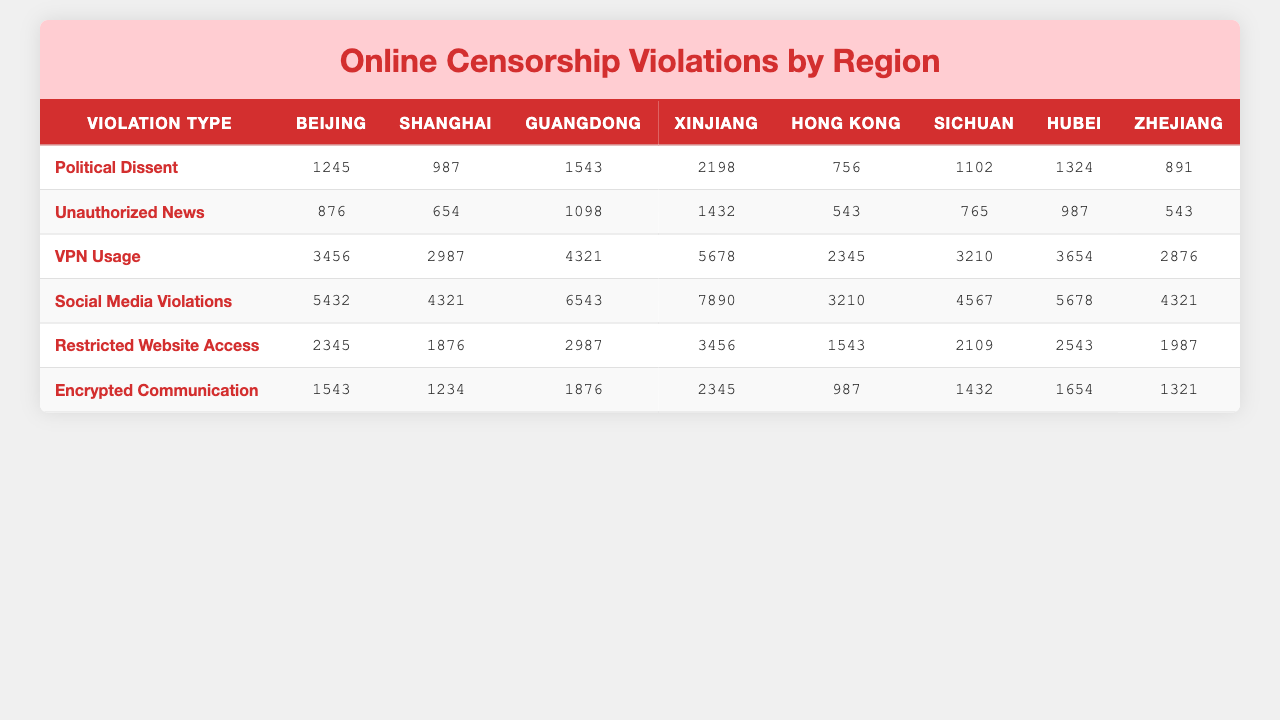What's the total frequency of Political Dissent violations in Beijing? The frequency of Political Dissent violations in Beijing is 1245. Since this is a direct retrieval question, we can simply refer to the number in the table.
Answer: 1245 Which region has the highest frequency of VPN Usage violations? The highest frequency of VPN Usage violations can be found by comparing the numbers across all regions. In this case, Xinjiang has the highest frequency at 5678.
Answer: Xinjiang What is the average frequency of Restricted Website Access violations across all regions? To calculate the average for Restricted Website Access violations, we sum the frequencies (2345 + 1876 + 2987 + 3456 + 1543 + 2109 + 2543 + 1987 = 18656) and divide by the number of regions (8). Thus, the average frequency is 18656 / 8 = 2332.
Answer: 2332 In which region is the frequency of Unauthorized News violations lower than 800? The frequency of Unauthorized News violations is lower than 800 only in Hong Kong (543). Since there is only one instance, we can confirm this directly from the table.
Answer: Hong Kong What is the total frequency of Social Media Violations across all regions combined? To find the total frequency, we sum all the values for Social Media Violations (5432 + 4321 + 6543 + 7890 + 3210 + 4567 + 5678 + 4321 = 40062).
Answer: 40062 Which violation type has the second highest frequency of violations in Shanghai? In Shanghai, looking at the frequencies: the highest violation is VPN Usage (2987), followed by Social Media Violations (4321). Thus, the second highest is Unauthorized News (654).
Answer: Unauthorized News Is the frequency of Encrypted Communication violations higher in Hubei than in Sichuan? The frequency of Encrypted Communication is 1654 in Hubei and 1432 in Sichuan. Since 1654 is greater than 1432, the answer is yes.
Answer: Yes What is the difference in frequency of Social Media Violations between Guangdong and Xinjiang? The frequency of Social Media Violations in Guangdong is 6543 and in Xinjiang is 7890. The difference is 7890 - 6543 = 1347.
Answer: 1347 Which violation type has the highest overall frequency, and what is that value? By summing the frequencies for all violation types and comparing, we find that Social Media Violations have the highest frequency total of 40062.
Answer: 40062 For which type of violation does Sichuan exhibit a frequency that exceeds 4000? Looking at the frequencies for Sichuan, both VPN Usage (3210) and Social Media Violations (4567) exceed 4000. Hence, only Social Media Violations qualifies.
Answer: Social Media Violations 